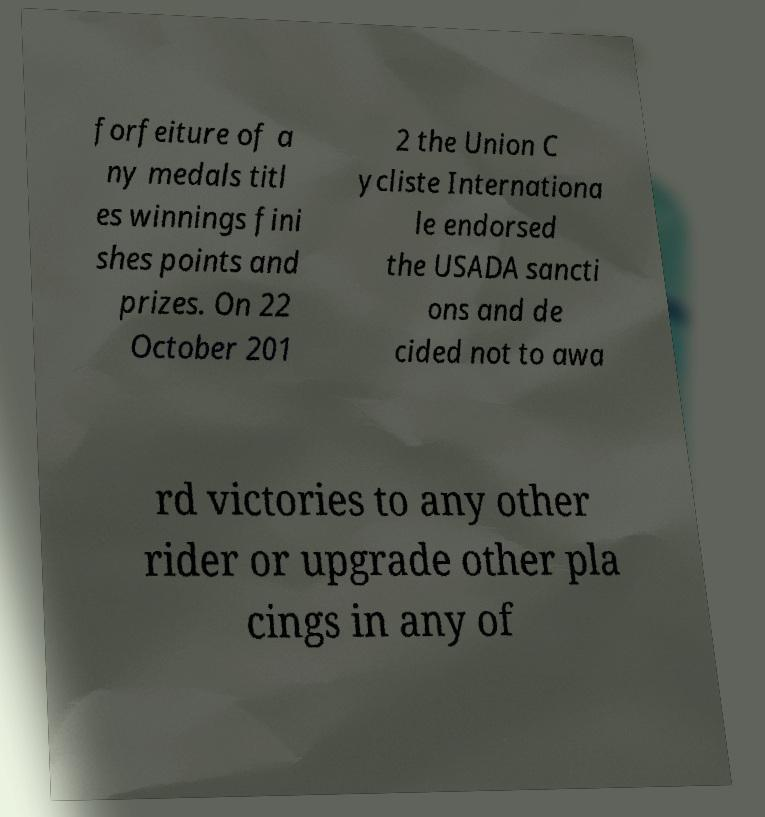I need the written content from this picture converted into text. Can you do that? forfeiture of a ny medals titl es winnings fini shes points and prizes. On 22 October 201 2 the Union C ycliste Internationa le endorsed the USADA sancti ons and de cided not to awa rd victories to any other rider or upgrade other pla cings in any of 